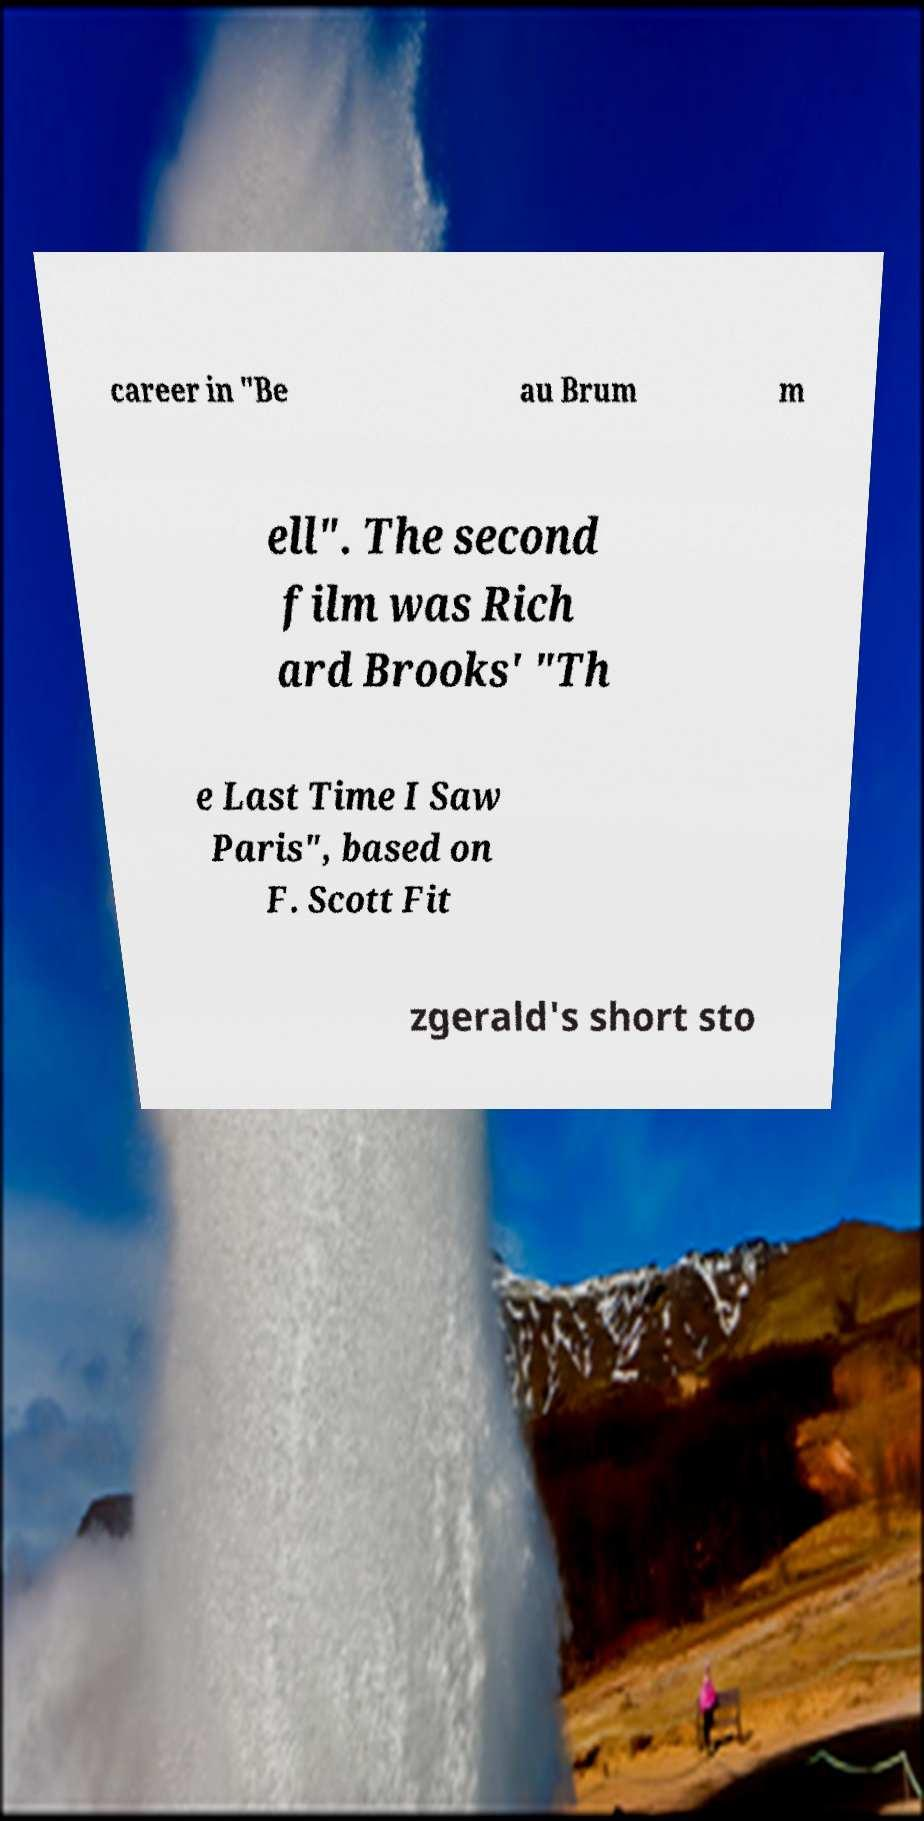Could you assist in decoding the text presented in this image and type it out clearly? career in "Be au Brum m ell". The second film was Rich ard Brooks' "Th e Last Time I Saw Paris", based on F. Scott Fit zgerald's short sto 